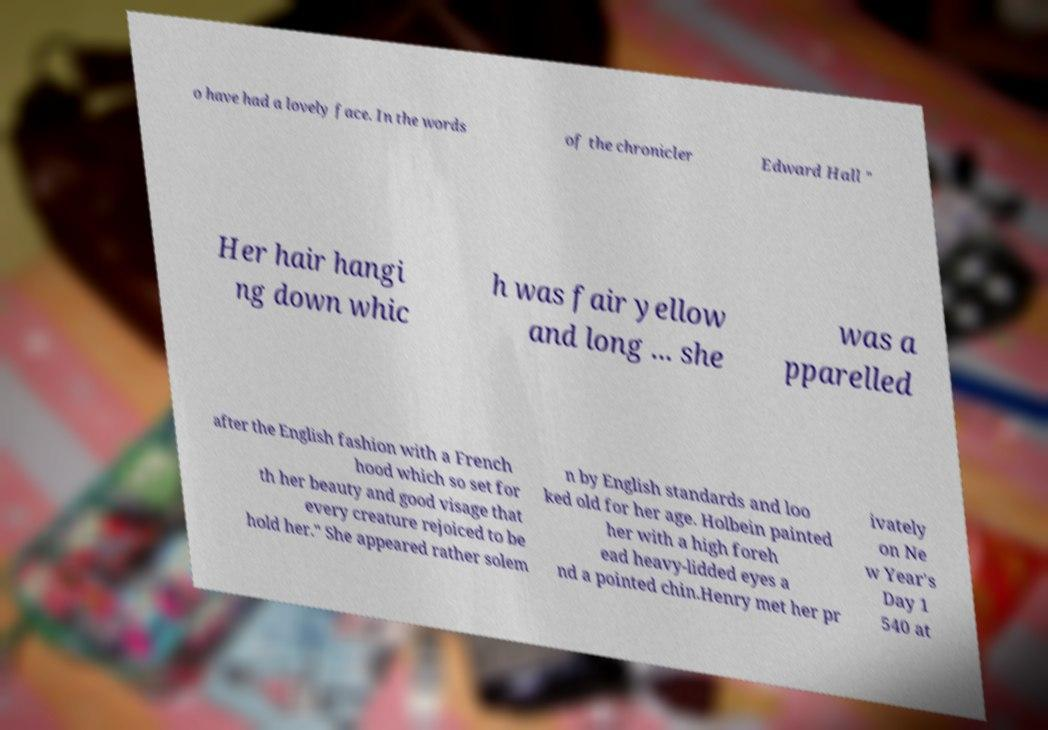I need the written content from this picture converted into text. Can you do that? o have had a lovely face. In the words of the chronicler Edward Hall " Her hair hangi ng down whic h was fair yellow and long ... she was a pparelled after the English fashion with a French hood which so set for th her beauty and good visage that every creature rejoiced to be hold her." She appeared rather solem n by English standards and loo ked old for her age. Holbein painted her with a high foreh ead heavy-lidded eyes a nd a pointed chin.Henry met her pr ivately on Ne w Year's Day 1 540 at 